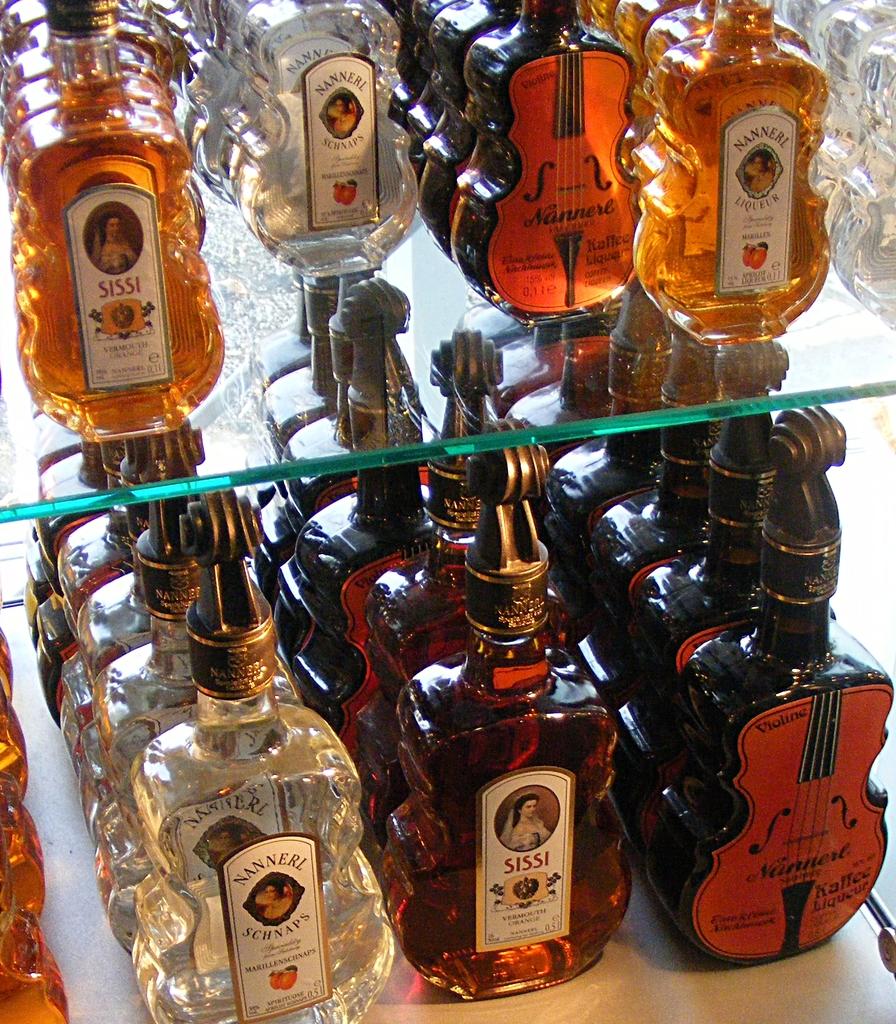What is the brand in the bottom left?
Ensure brevity in your answer.  Nannerl schnaps. What brand is the bottle on the bottom in the center?
Your answer should be compact. Sissi. 